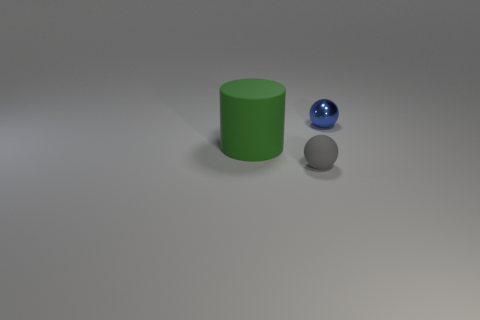How do the sizes of the green cylinder and the blue sphere compare? The green cylinder is taller and wider than the blue sphere, suggesting a larger overall volume. 